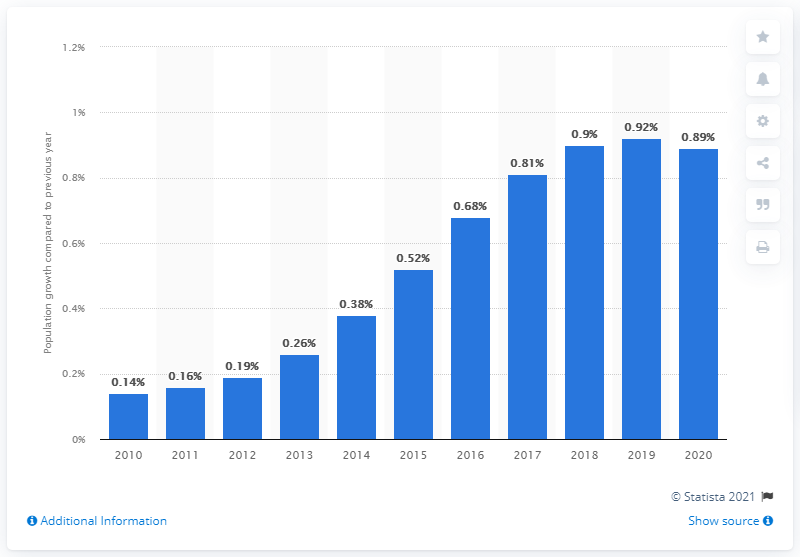Highlight a few significant elements in this photo. According to data released in 2020, the population of Guam grew by 0.89%. 